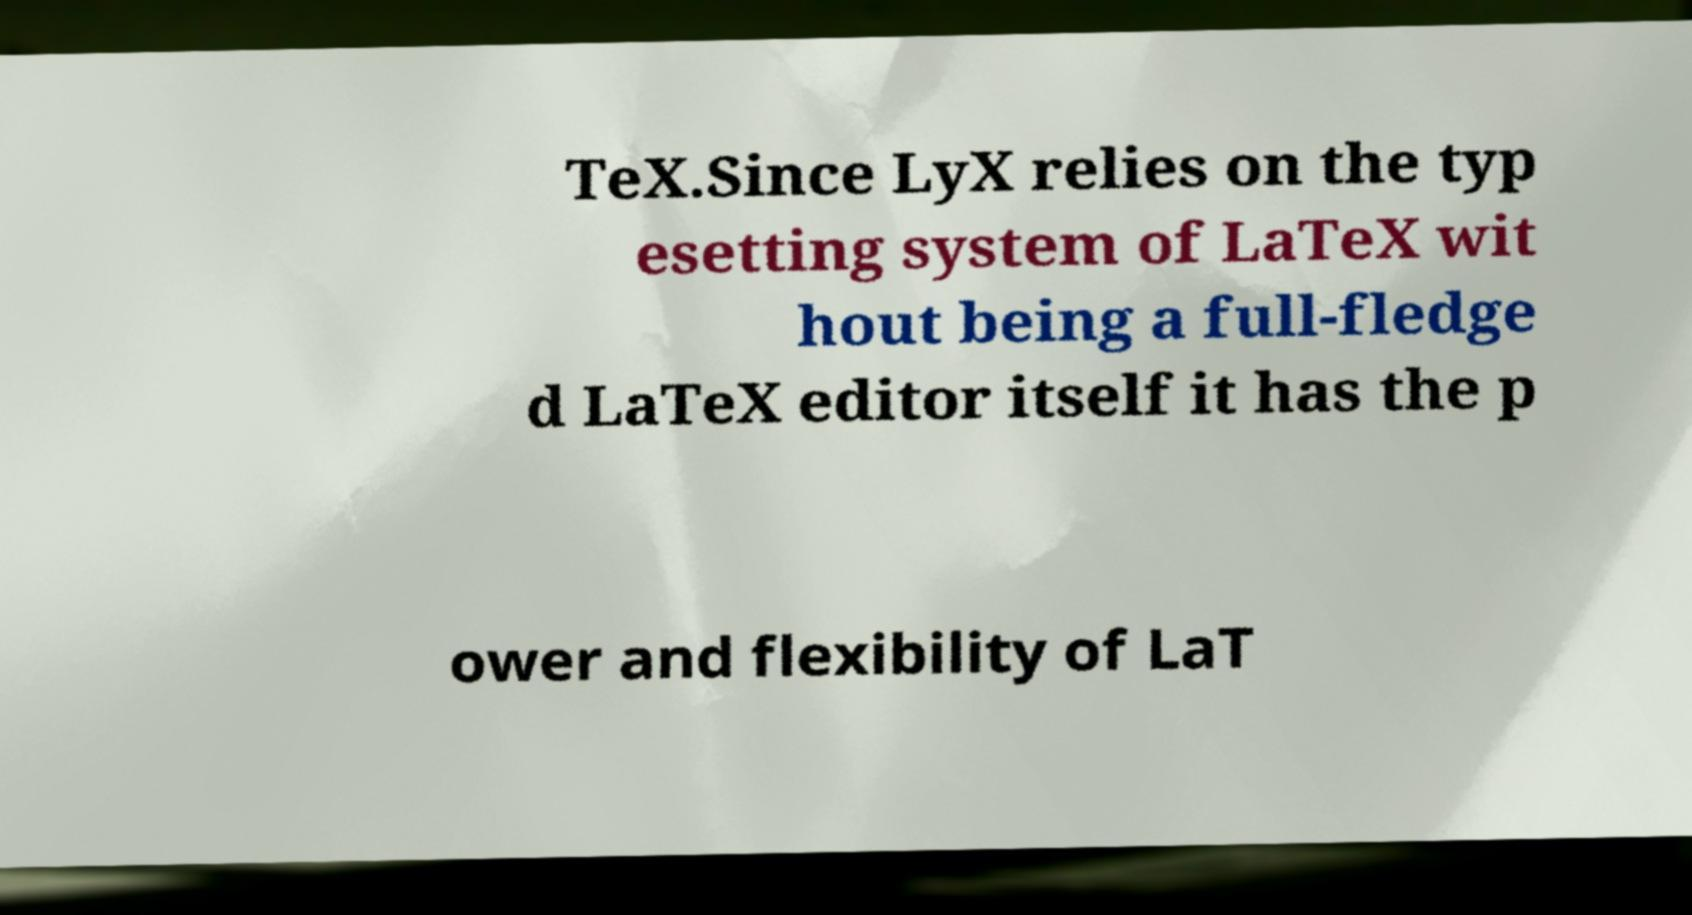For documentation purposes, I need the text within this image transcribed. Could you provide that? TeX.Since LyX relies on the typ esetting system of LaTeX wit hout being a full-fledge d LaTeX editor itself it has the p ower and flexibility of LaT 